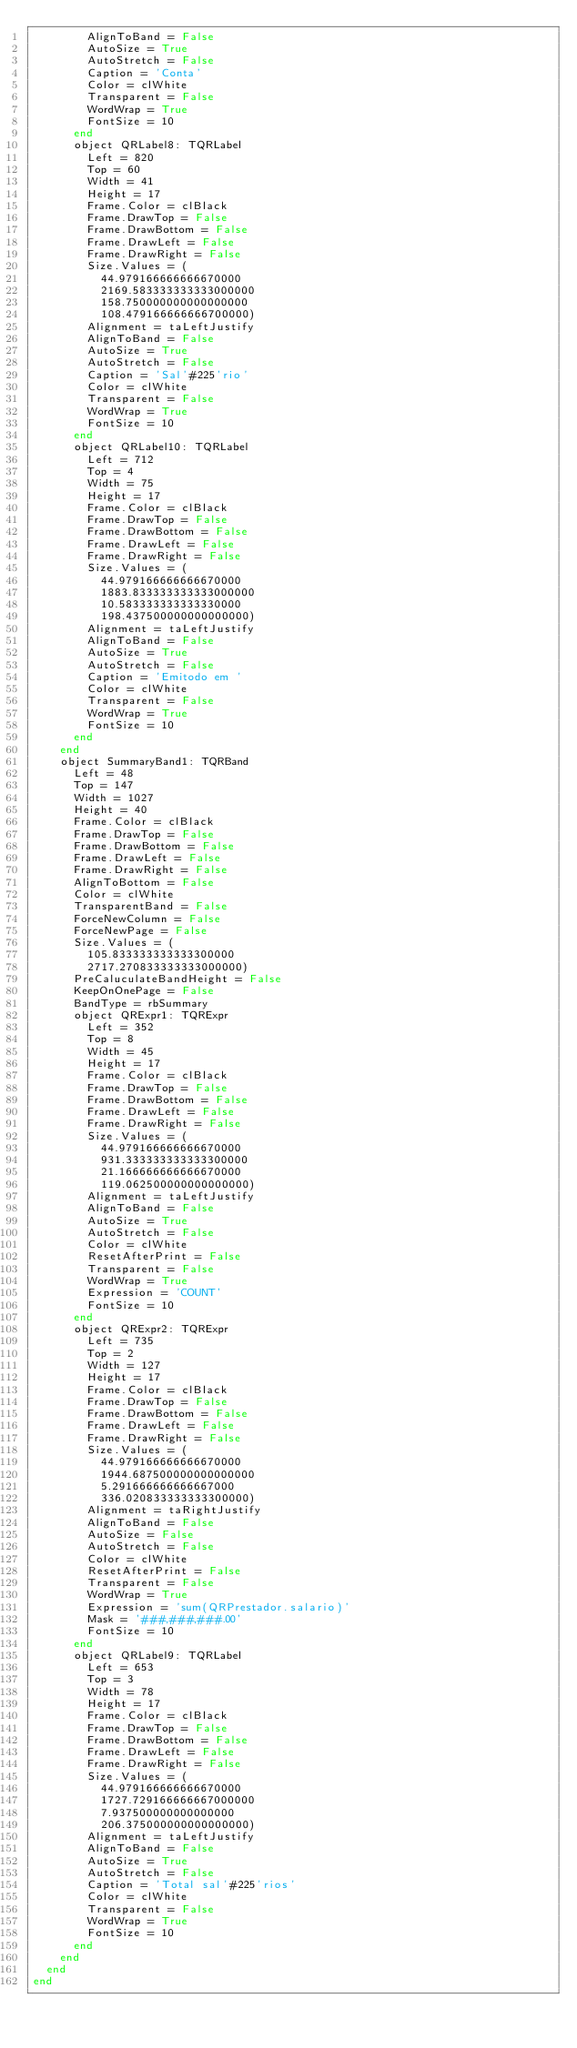<code> <loc_0><loc_0><loc_500><loc_500><_Pascal_>        AlignToBand = False
        AutoSize = True
        AutoStretch = False
        Caption = 'Conta'
        Color = clWhite
        Transparent = False
        WordWrap = True
        FontSize = 10
      end
      object QRLabel8: TQRLabel
        Left = 820
        Top = 60
        Width = 41
        Height = 17
        Frame.Color = clBlack
        Frame.DrawTop = False
        Frame.DrawBottom = False
        Frame.DrawLeft = False
        Frame.DrawRight = False
        Size.Values = (
          44.979166666666670000
          2169.583333333333000000
          158.750000000000000000
          108.479166666666700000)
        Alignment = taLeftJustify
        AlignToBand = False
        AutoSize = True
        AutoStretch = False
        Caption = 'Sal'#225'rio'
        Color = clWhite
        Transparent = False
        WordWrap = True
        FontSize = 10
      end
      object QRLabel10: TQRLabel
        Left = 712
        Top = 4
        Width = 75
        Height = 17
        Frame.Color = clBlack
        Frame.DrawTop = False
        Frame.DrawBottom = False
        Frame.DrawLeft = False
        Frame.DrawRight = False
        Size.Values = (
          44.979166666666670000
          1883.833333333333000000
          10.583333333333330000
          198.437500000000000000)
        Alignment = taLeftJustify
        AlignToBand = False
        AutoSize = True
        AutoStretch = False
        Caption = 'Emitodo em '
        Color = clWhite
        Transparent = False
        WordWrap = True
        FontSize = 10
      end
    end
    object SummaryBand1: TQRBand
      Left = 48
      Top = 147
      Width = 1027
      Height = 40
      Frame.Color = clBlack
      Frame.DrawTop = False
      Frame.DrawBottom = False
      Frame.DrawLeft = False
      Frame.DrawRight = False
      AlignToBottom = False
      Color = clWhite
      TransparentBand = False
      ForceNewColumn = False
      ForceNewPage = False
      Size.Values = (
        105.833333333333300000
        2717.270833333333000000)
      PreCaluculateBandHeight = False
      KeepOnOnePage = False
      BandType = rbSummary
      object QRExpr1: TQRExpr
        Left = 352
        Top = 8
        Width = 45
        Height = 17
        Frame.Color = clBlack
        Frame.DrawTop = False
        Frame.DrawBottom = False
        Frame.DrawLeft = False
        Frame.DrawRight = False
        Size.Values = (
          44.979166666666670000
          931.333333333333300000
          21.166666666666670000
          119.062500000000000000)
        Alignment = taLeftJustify
        AlignToBand = False
        AutoSize = True
        AutoStretch = False
        Color = clWhite
        ResetAfterPrint = False
        Transparent = False
        WordWrap = True
        Expression = 'COUNT'
        FontSize = 10
      end
      object QRExpr2: TQRExpr
        Left = 735
        Top = 2
        Width = 127
        Height = 17
        Frame.Color = clBlack
        Frame.DrawTop = False
        Frame.DrawBottom = False
        Frame.DrawLeft = False
        Frame.DrawRight = False
        Size.Values = (
          44.979166666666670000
          1944.687500000000000000
          5.291666666666667000
          336.020833333333300000)
        Alignment = taRightJustify
        AlignToBand = False
        AutoSize = False
        AutoStretch = False
        Color = clWhite
        ResetAfterPrint = False
        Transparent = False
        WordWrap = True
        Expression = 'sum(QRPrestador.salario)'
        Mask = '###,###,###.00'
        FontSize = 10
      end
      object QRLabel9: TQRLabel
        Left = 653
        Top = 3
        Width = 78
        Height = 17
        Frame.Color = clBlack
        Frame.DrawTop = False
        Frame.DrawBottom = False
        Frame.DrawLeft = False
        Frame.DrawRight = False
        Size.Values = (
          44.979166666666670000
          1727.729166666667000000
          7.937500000000000000
          206.375000000000000000)
        Alignment = taLeftJustify
        AlignToBand = False
        AutoSize = True
        AutoStretch = False
        Caption = 'Total sal'#225'rios'
        Color = clWhite
        Transparent = False
        WordWrap = True
        FontSize = 10
      end
    end
  end
end
</code> 